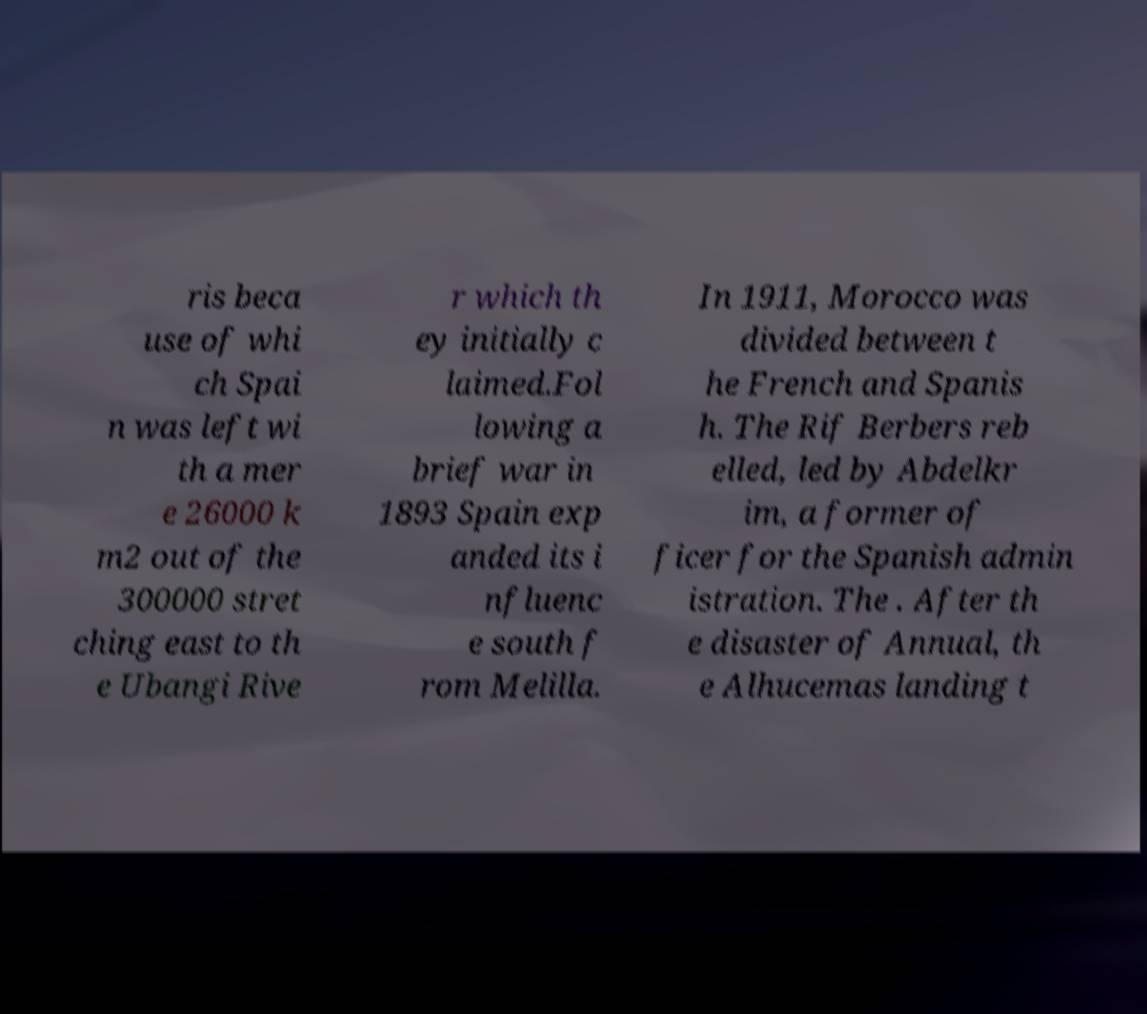Can you read and provide the text displayed in the image?This photo seems to have some interesting text. Can you extract and type it out for me? ris beca use of whi ch Spai n was left wi th a mer e 26000 k m2 out of the 300000 stret ching east to th e Ubangi Rive r which th ey initially c laimed.Fol lowing a brief war in 1893 Spain exp anded its i nfluenc e south f rom Melilla. In 1911, Morocco was divided between t he French and Spanis h. The Rif Berbers reb elled, led by Abdelkr im, a former of ficer for the Spanish admin istration. The . After th e disaster of Annual, th e Alhucemas landing t 